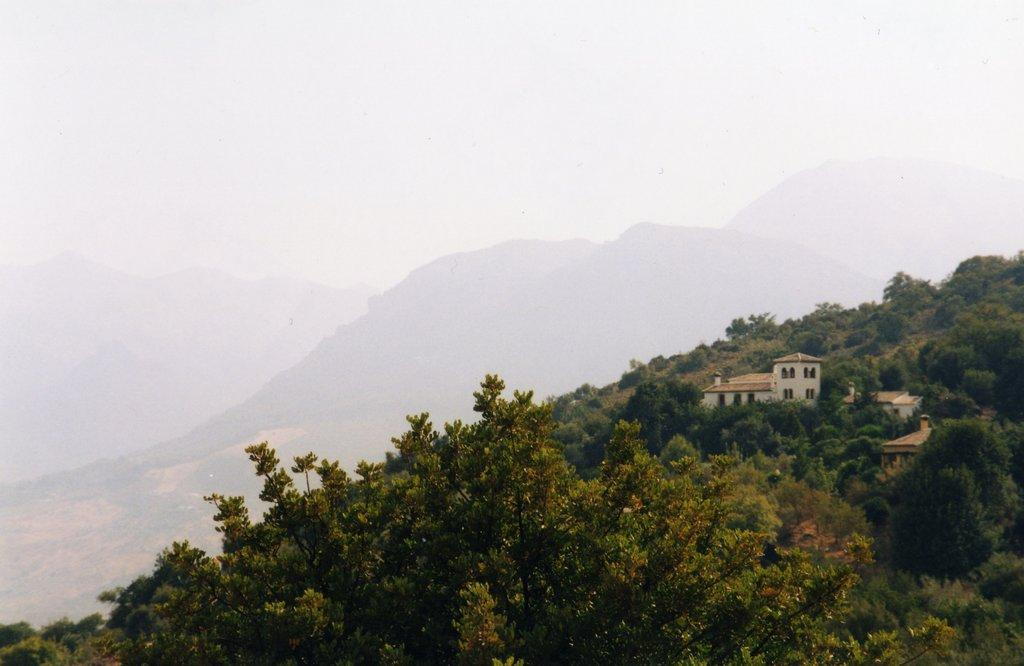What is the primary feature of the landscape in the image? There are many trees in the image. What type of structures can be seen to the right of the image? There are houses visible to the right of the image. What is visible in the distance in the image? Mountains and the sky are visible in the background of the image. Where are the scissors located in the image? There are no scissors present in the image. What type of food is being cooked in the oven in the image? There is no oven present in the image. 